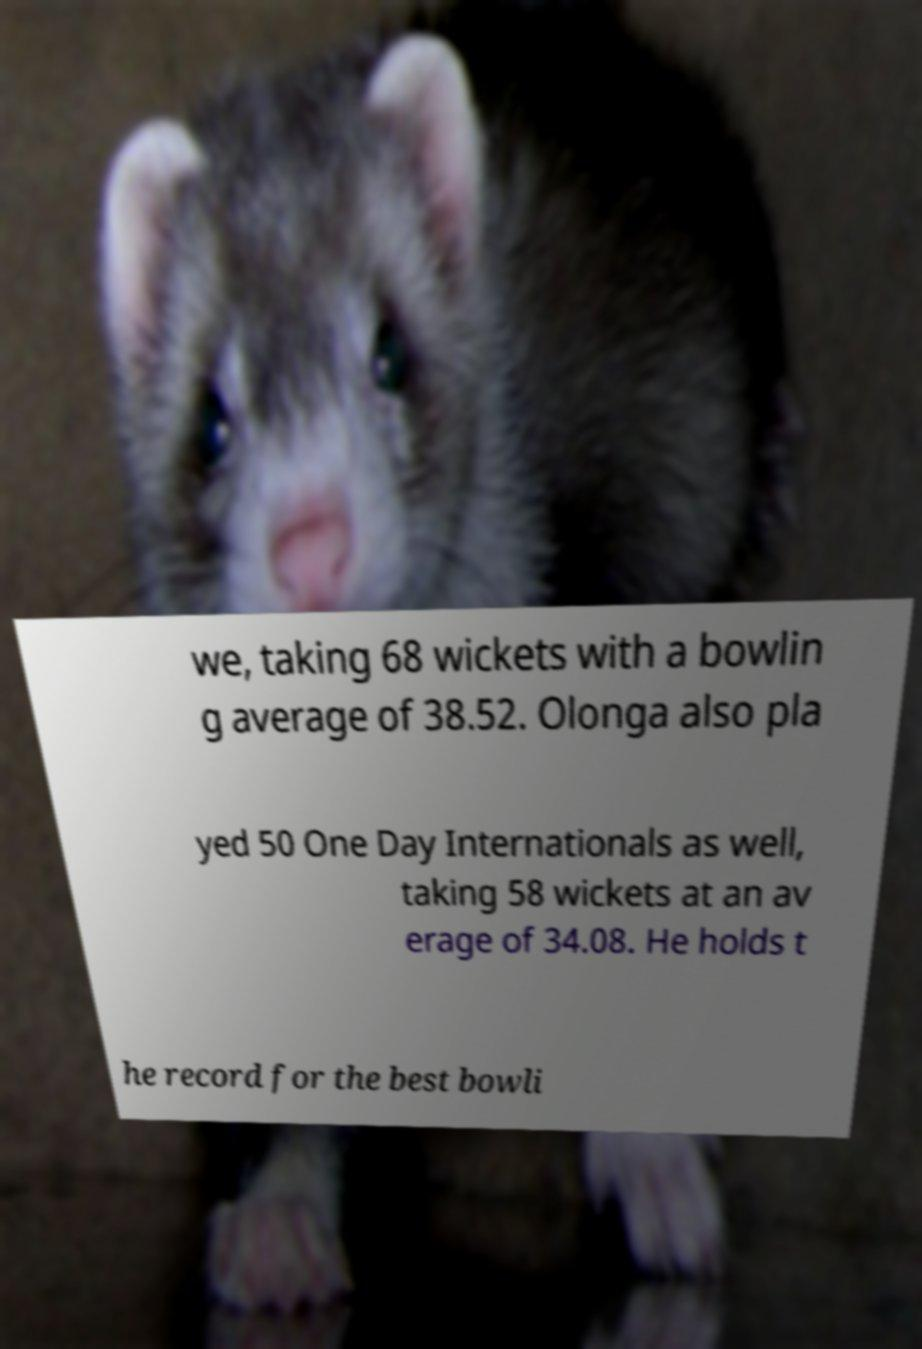Could you extract and type out the text from this image? we, taking 68 wickets with a bowlin g average of 38.52. Olonga also pla yed 50 One Day Internationals as well, taking 58 wickets at an av erage of 34.08. He holds t he record for the best bowli 